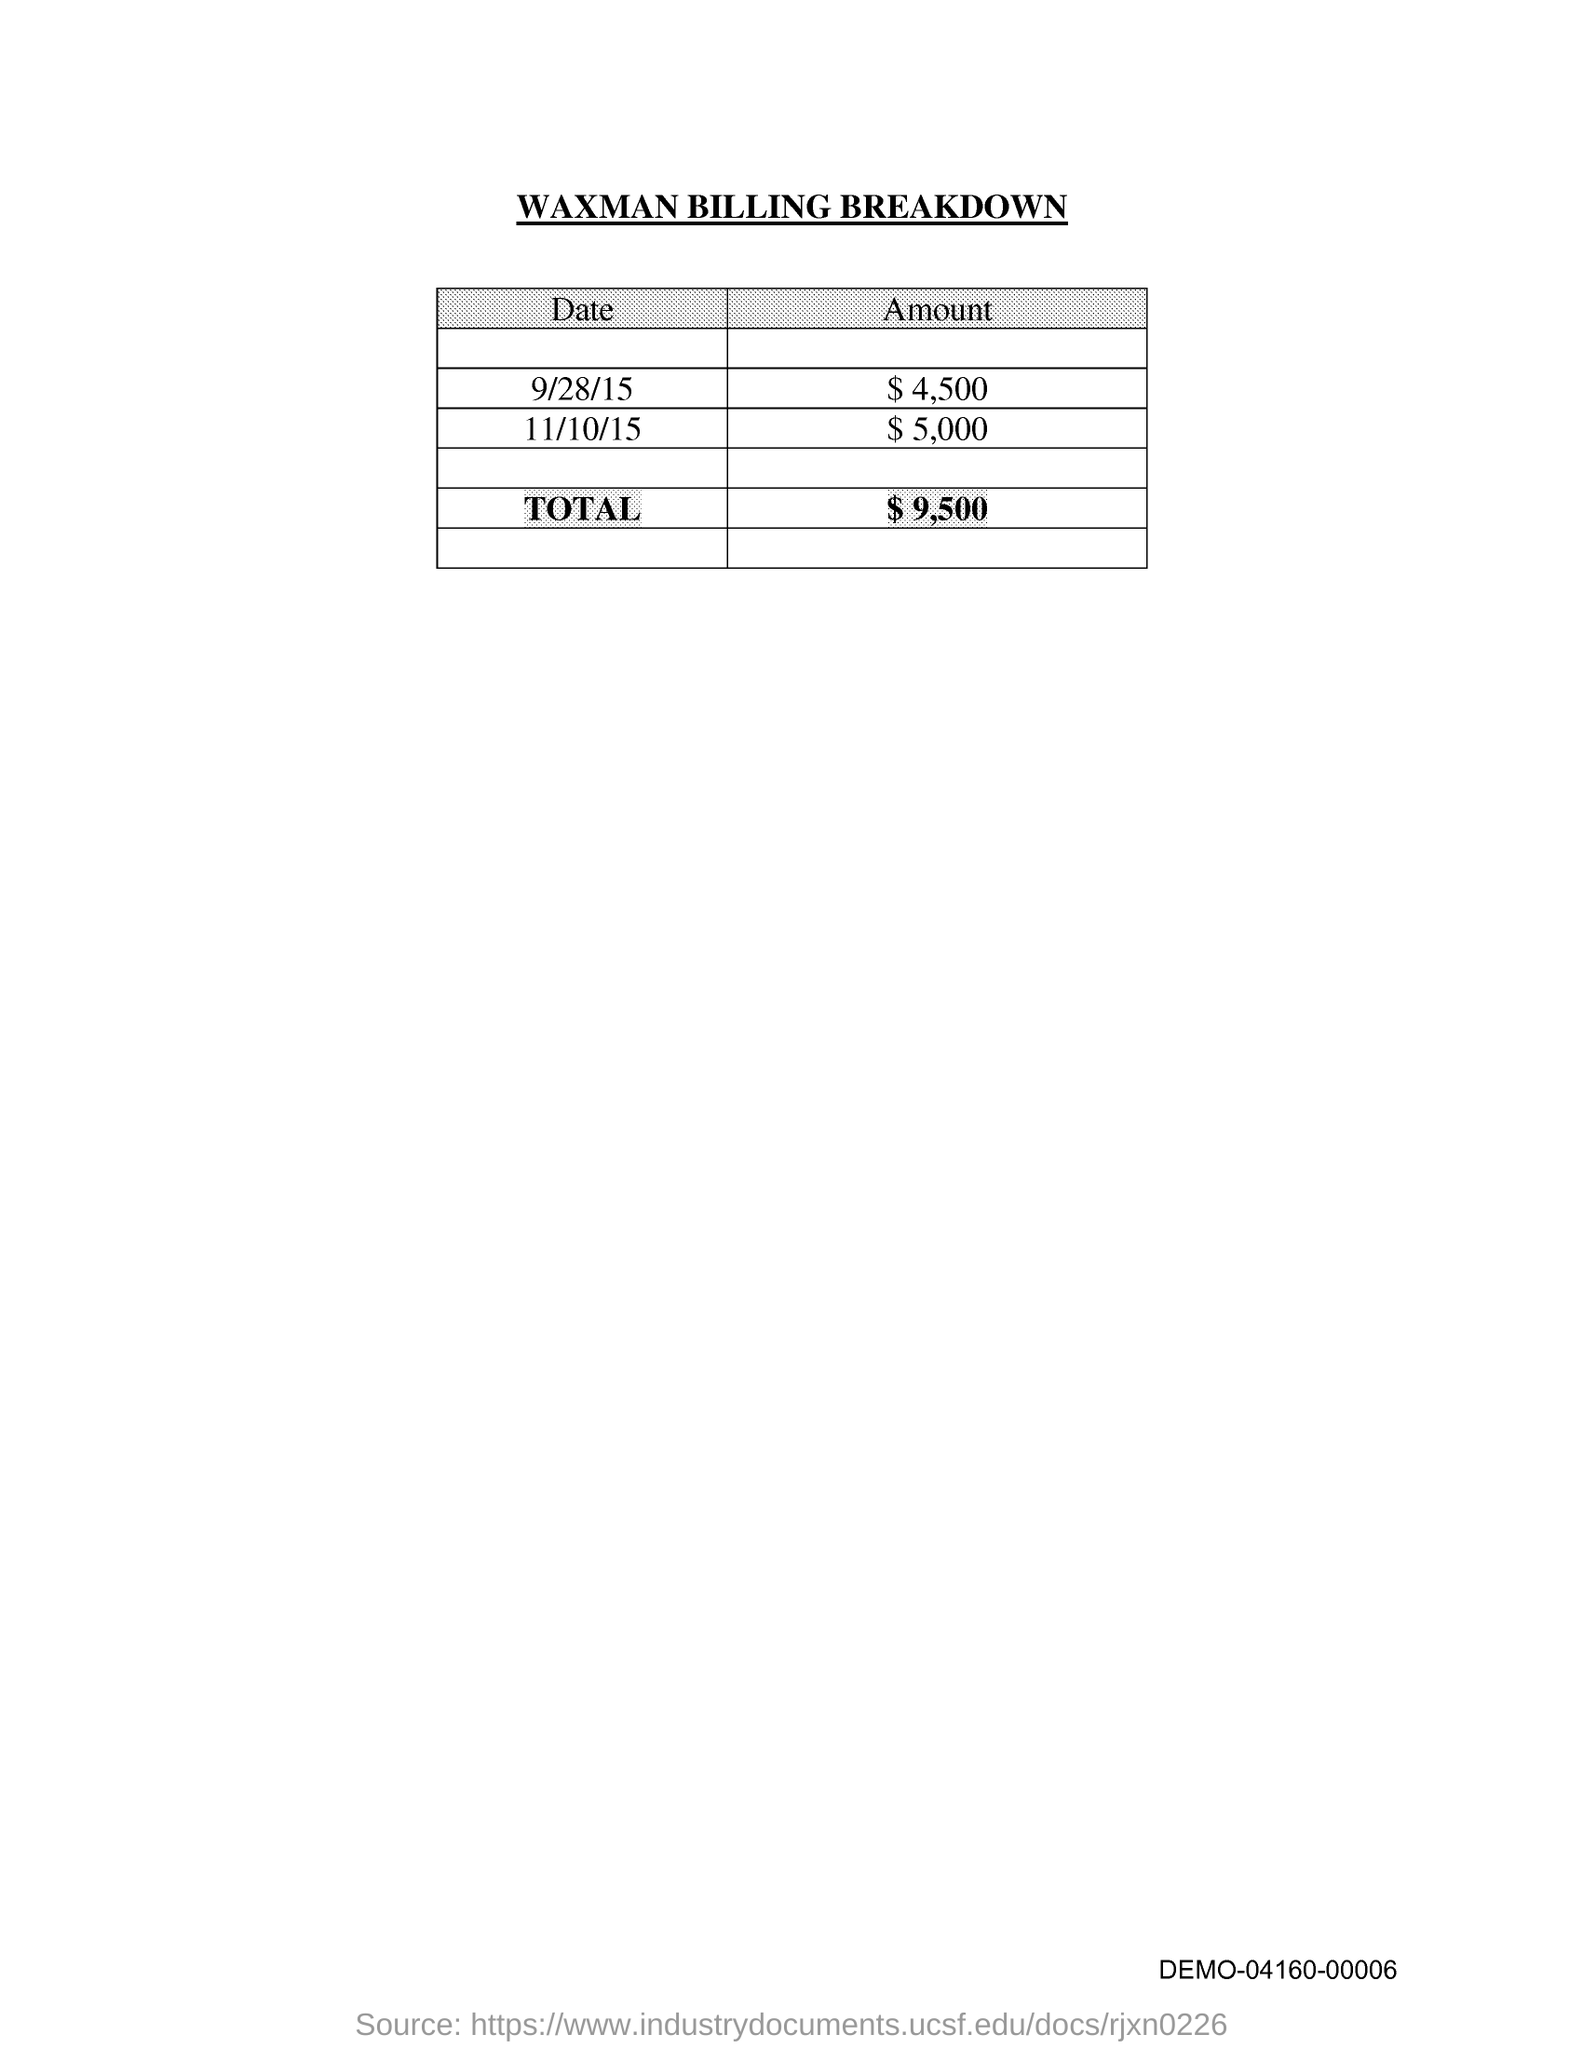What is the total amount of the bill?
Your answer should be very brief. $9,500. What is the amount of the bill on 9/28/15?
Make the answer very short. $ 4,500. What is the amount of the bill on 11/10/15?
Make the answer very short. $5,000. What is the title of this document?
Your answer should be very brief. WAXMAN BILLING BREAKDOWN. 